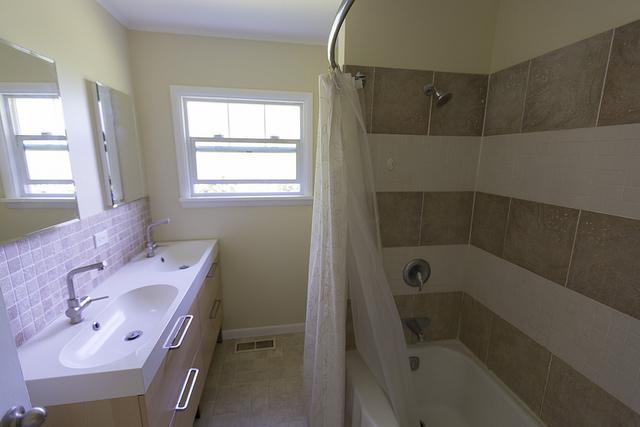How many giraffes are sitting there?
Give a very brief answer. 0. 